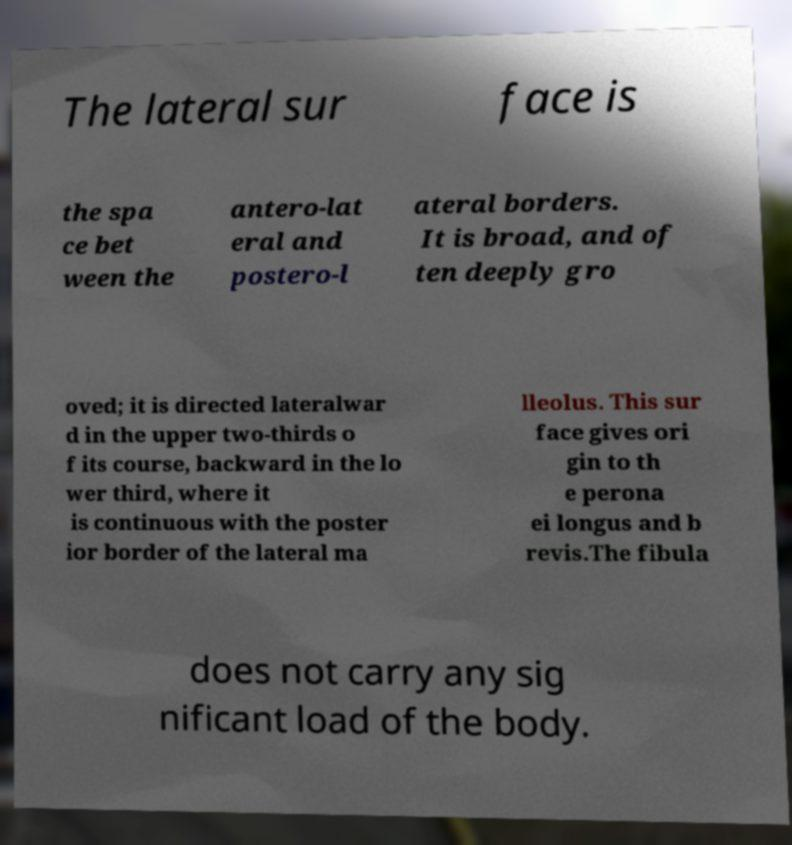Please identify and transcribe the text found in this image. The lateral sur face is the spa ce bet ween the antero-lat eral and postero-l ateral borders. It is broad, and of ten deeply gro oved; it is directed lateralwar d in the upper two-thirds o f its course, backward in the lo wer third, where it is continuous with the poster ior border of the lateral ma lleolus. This sur face gives ori gin to th e perona ei longus and b revis.The fibula does not carry any sig nificant load of the body. 